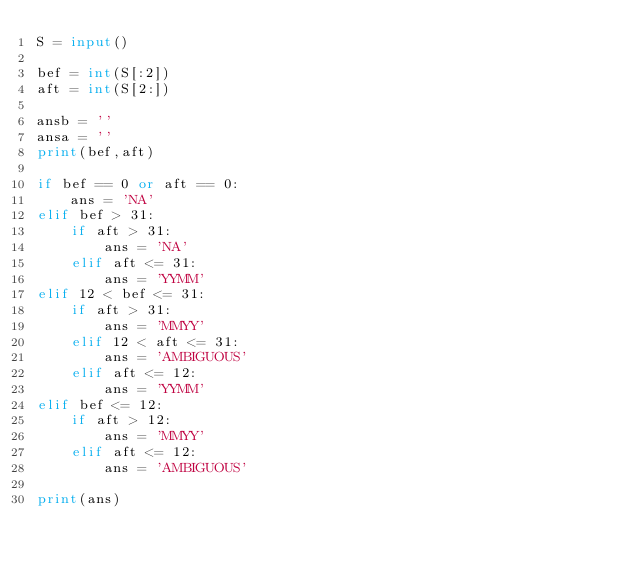Convert code to text. <code><loc_0><loc_0><loc_500><loc_500><_Python_>S = input()

bef = int(S[:2])
aft = int(S[2:])

ansb = ''
ansa = ''
print(bef,aft)

if bef == 0 or aft == 0:
    ans = 'NA'
elif bef > 31:
    if aft > 31:
        ans = 'NA'
    elif aft <= 31:
        ans = 'YYMM'
elif 12 < bef <= 31:
    if aft > 31:
        ans = 'MMYY'
    elif 12 < aft <= 31:
        ans = 'AMBIGUOUS'
    elif aft <= 12:
        ans = 'YYMM'
elif bef <= 12:
    if aft > 12:
        ans = 'MMYY'
    elif aft <= 12:
        ans = 'AMBIGUOUS'

print(ans)
</code> 